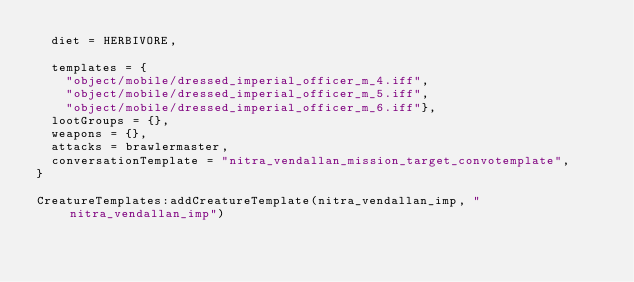<code> <loc_0><loc_0><loc_500><loc_500><_Lua_>	diet = HERBIVORE,

	templates = {
		"object/mobile/dressed_imperial_officer_m_4.iff",
		"object/mobile/dressed_imperial_officer_m_5.iff",
		"object/mobile/dressed_imperial_officer_m_6.iff"},
	lootGroups = {},
	weapons = {},
	attacks = brawlermaster,
	conversationTemplate = "nitra_vendallan_mission_target_convotemplate",	
}

CreatureTemplates:addCreatureTemplate(nitra_vendallan_imp, "nitra_vendallan_imp")
</code> 